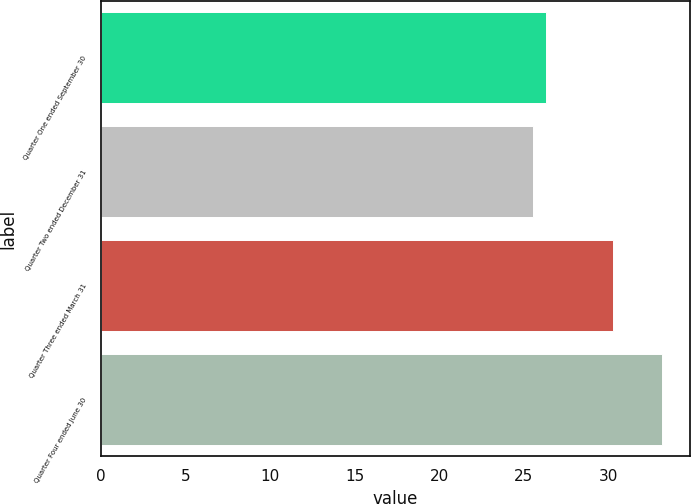<chart> <loc_0><loc_0><loc_500><loc_500><bar_chart><fcel>Quarter One ended September 30<fcel>Quarter Two ended December 31<fcel>Quarter Three ended March 31<fcel>Quarter Four ended June 30<nl><fcel>26.31<fcel>25.55<fcel>30.25<fcel>33.14<nl></chart> 